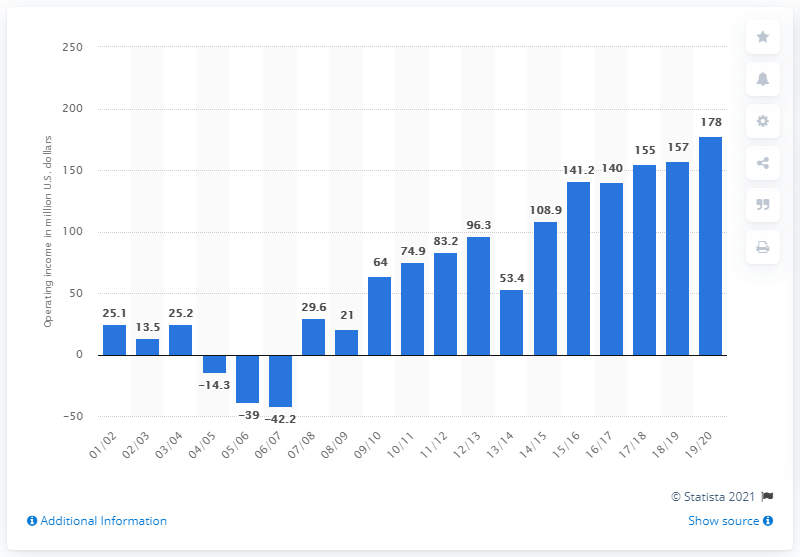Specify some key components in this picture. The operating income of the New York Knicks in the 2019/20 season was $178 million. 